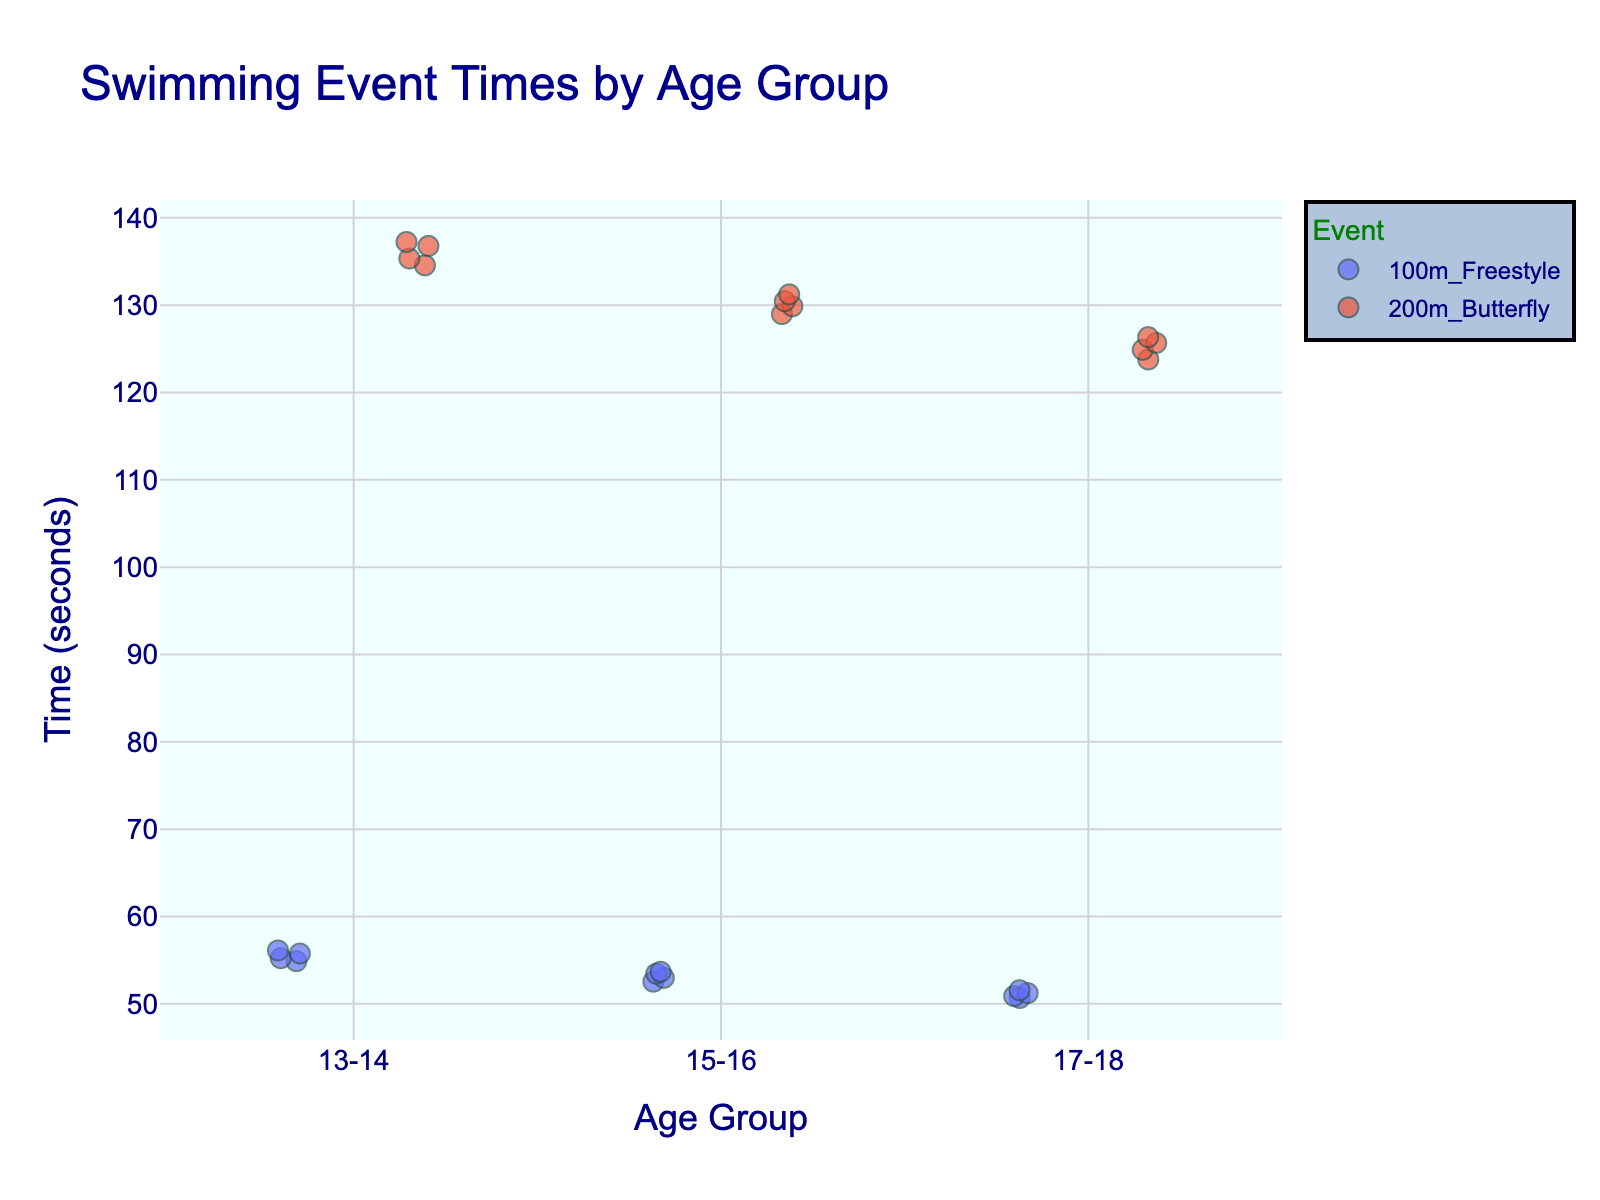What is the title of the figure? Look at the top of the figure where the title is usually placed. The title of the figure should describe what is being shown.
Answer: Swimming Event Times by Age Group What are the age groups displayed on the x-axis? Check the x-axis of the plot to see the categories listed. These represent the different age groups in the swimming competitions.
Answer: 13-14, 15-16, 17-18 What color is used for the '100m Freestyle' event? On the figure, each event is represented by different colors. Identify the color used for the '100m Freestyle' event from the plot's legend.
Answer: Refer to legend in plot (color varies) Which event, '100m Freestyle' or '200m Butterfly', has the faster times in the 15-16 age group? Compare the positions of the data points for both events within the 15-16 age group. The event with the lower y-values has faster times.
Answer: 100m Freestyle What is the fastest recorded time in the 200m Butterfly for the 13-14 age group? Look at the position of the lowest point for the 200m Butterfly within the 13-14 age group. The y-value of this point represents the fastest time.
Answer: 2:14.56 Which age group has the most clustered times for the '100m Freestyle' event? Look at the spread of the points for the '100m Freestyle' event across different age groups. The group with the least spread/clustering has the most clustered times.
Answer: 17-18 